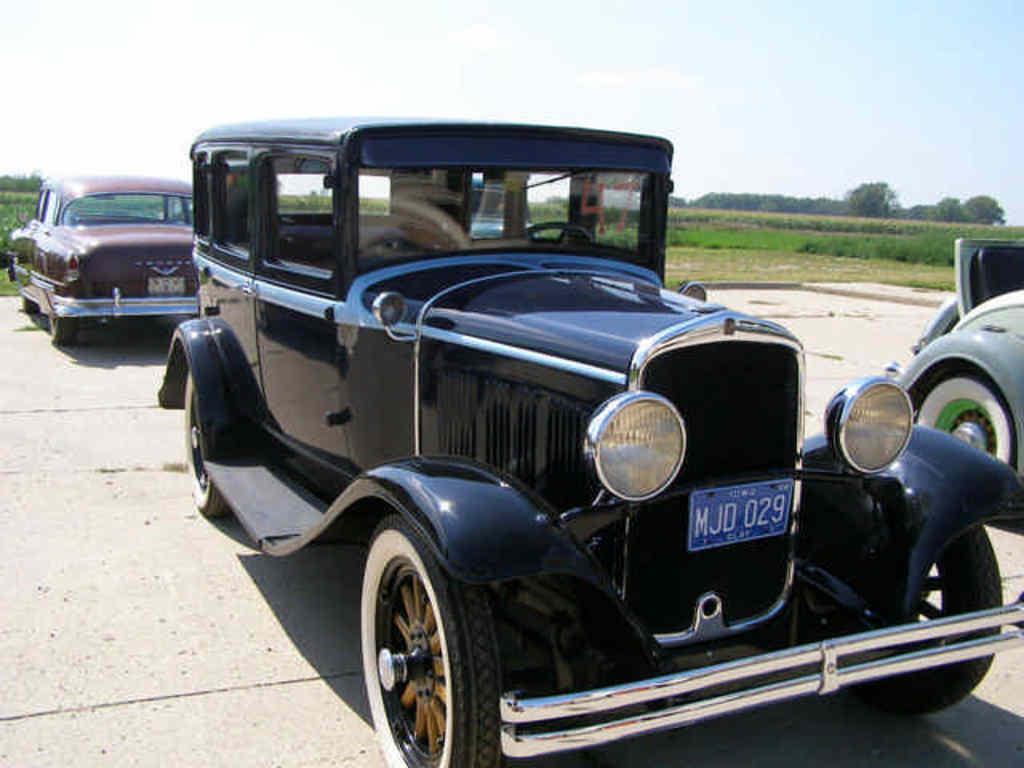In one or two sentences, can you explain what this image depicts? In the foreground of this image, there are three vehicles on the ground. In the background, there is greenery. At the top, there is the sky. 